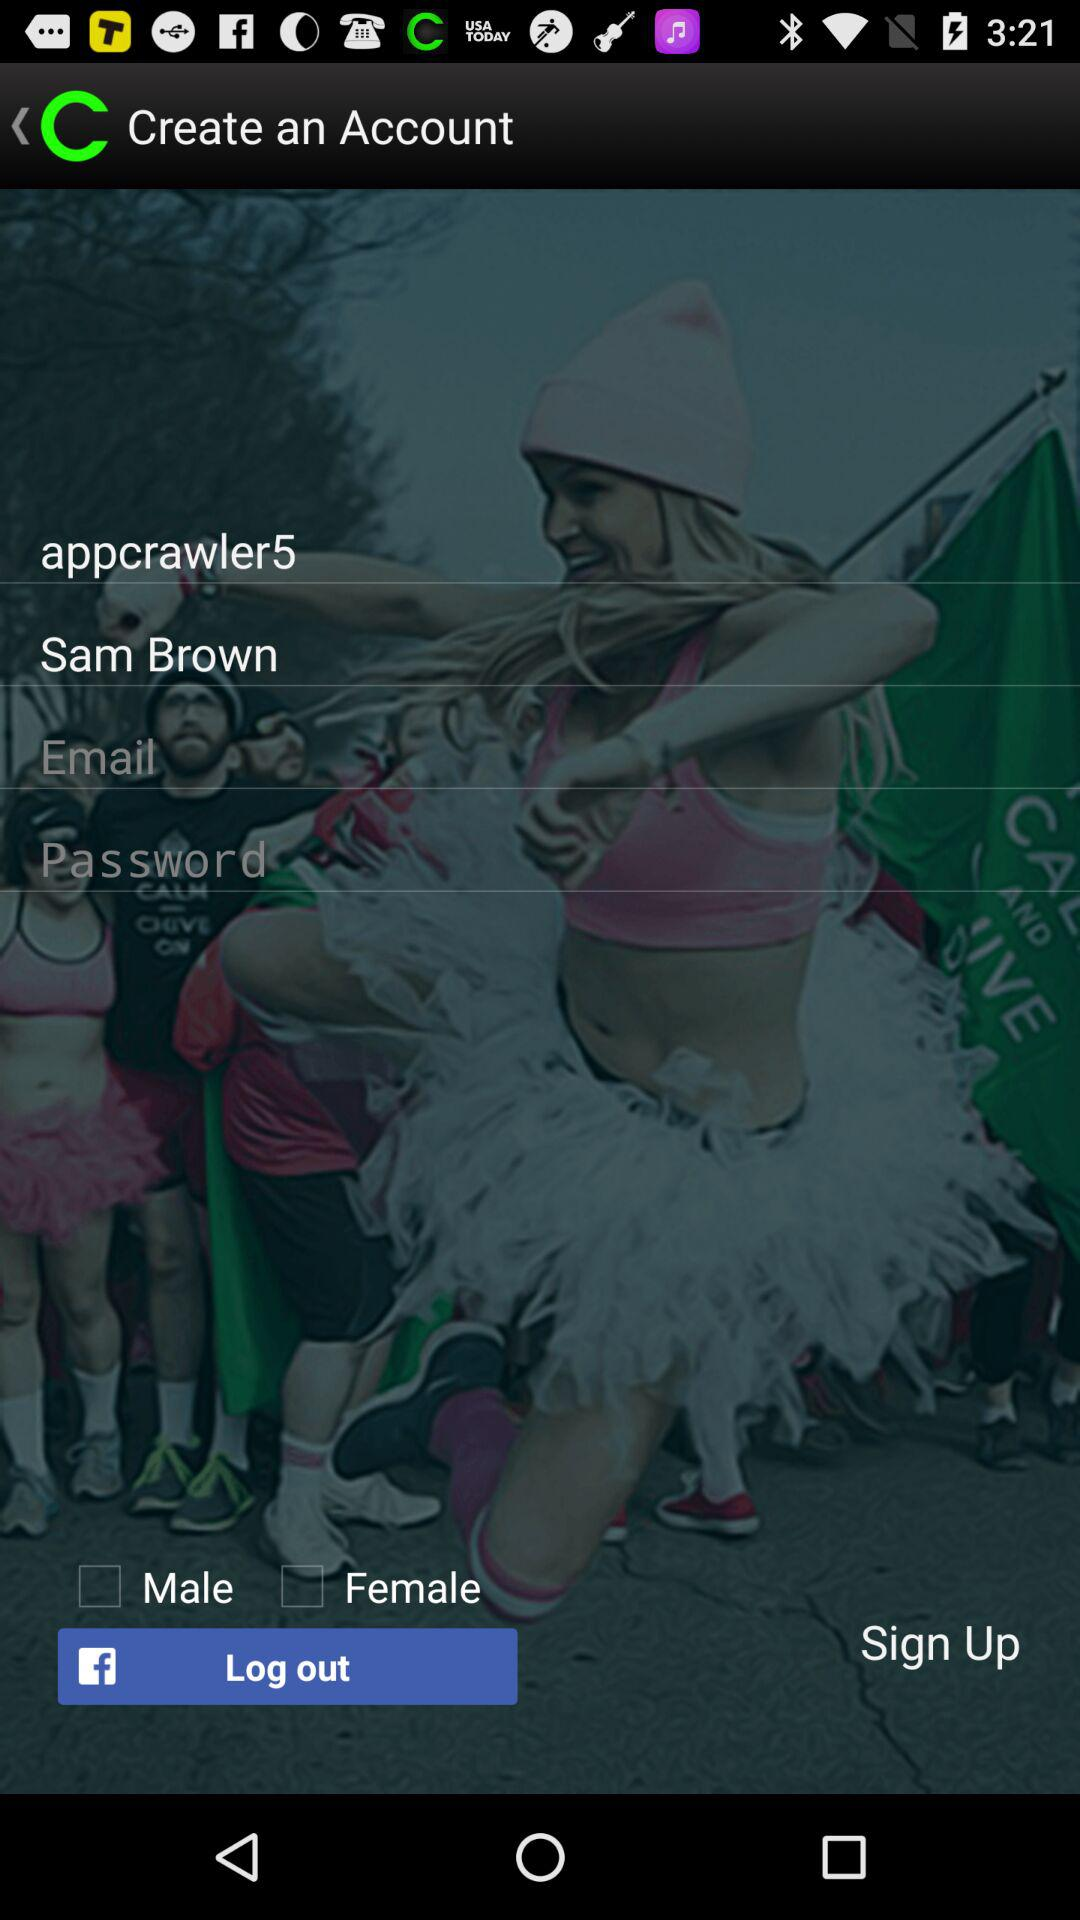How many characters are required to create a password?
When the provided information is insufficient, respond with <no answer>. <no answer> 